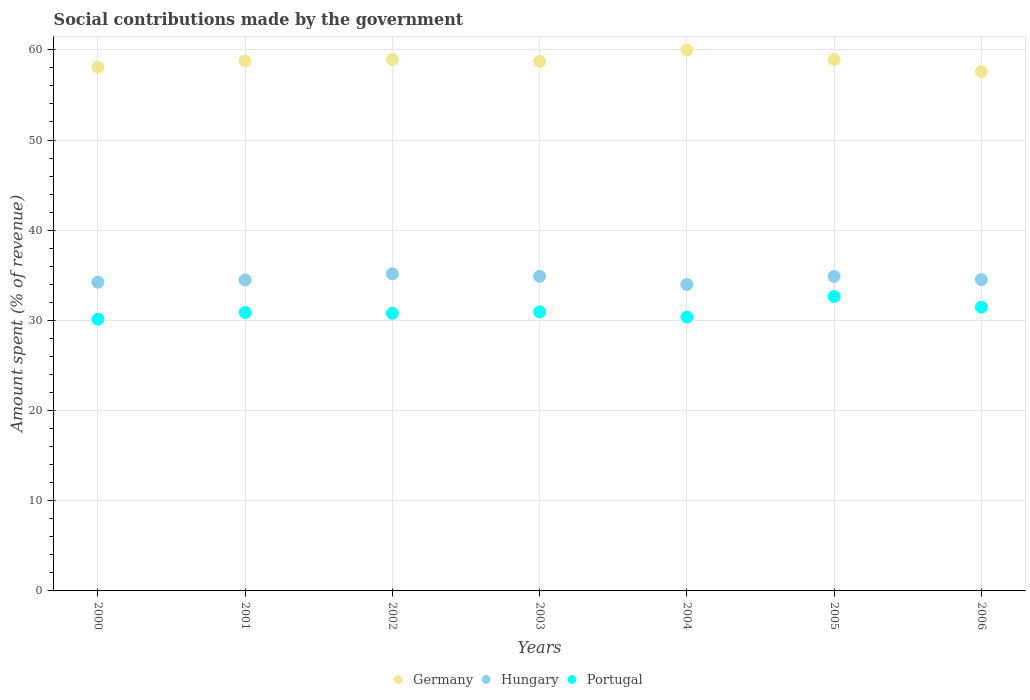What is the amount spent (in %) on social contributions in Portugal in 2006?
Your answer should be compact. 31.47. Across all years, what is the maximum amount spent (in %) on social contributions in Portugal?
Offer a terse response. 32.65. Across all years, what is the minimum amount spent (in %) on social contributions in Germany?
Offer a terse response. 57.59. In which year was the amount spent (in %) on social contributions in Portugal maximum?
Give a very brief answer. 2005. What is the total amount spent (in %) on social contributions in Portugal in the graph?
Provide a succinct answer. 217.23. What is the difference between the amount spent (in %) on social contributions in Hungary in 2005 and that in 2006?
Keep it short and to the point. 0.36. What is the difference between the amount spent (in %) on social contributions in Germany in 2003 and the amount spent (in %) on social contributions in Portugal in 2005?
Offer a very short reply. 26.08. What is the average amount spent (in %) on social contributions in Hungary per year?
Offer a very short reply. 34.59. In the year 2002, what is the difference between the amount spent (in %) on social contributions in Portugal and amount spent (in %) on social contributions in Hungary?
Offer a terse response. -4.37. In how many years, is the amount spent (in %) on social contributions in Germany greater than 14 %?
Your answer should be very brief. 7. What is the ratio of the amount spent (in %) on social contributions in Germany in 2001 to that in 2004?
Ensure brevity in your answer.  0.98. Is the amount spent (in %) on social contributions in Portugal in 2002 less than that in 2003?
Ensure brevity in your answer.  Yes. What is the difference between the highest and the second highest amount spent (in %) on social contributions in Portugal?
Give a very brief answer. 1.18. What is the difference between the highest and the lowest amount spent (in %) on social contributions in Portugal?
Ensure brevity in your answer.  2.52. In how many years, is the amount spent (in %) on social contributions in Portugal greater than the average amount spent (in %) on social contributions in Portugal taken over all years?
Provide a succinct answer. 2. Is the sum of the amount spent (in %) on social contributions in Hungary in 2001 and 2002 greater than the maximum amount spent (in %) on social contributions in Portugal across all years?
Your answer should be very brief. Yes. Is the amount spent (in %) on social contributions in Hungary strictly less than the amount spent (in %) on social contributions in Portugal over the years?
Make the answer very short. No. How many dotlines are there?
Make the answer very short. 3. How many years are there in the graph?
Your answer should be compact. 7. What is the difference between two consecutive major ticks on the Y-axis?
Your response must be concise. 10. Does the graph contain any zero values?
Offer a terse response. No. How many legend labels are there?
Give a very brief answer. 3. What is the title of the graph?
Offer a very short reply. Social contributions made by the government. Does "Pacific island small states" appear as one of the legend labels in the graph?
Your answer should be very brief. No. What is the label or title of the Y-axis?
Offer a very short reply. Amount spent (% of revenue). What is the Amount spent (% of revenue) of Germany in 2000?
Offer a terse response. 58.08. What is the Amount spent (% of revenue) in Hungary in 2000?
Your response must be concise. 34.24. What is the Amount spent (% of revenue) in Portugal in 2000?
Give a very brief answer. 30.13. What is the Amount spent (% of revenue) in Germany in 2001?
Provide a succinct answer. 58.78. What is the Amount spent (% of revenue) of Hungary in 2001?
Your answer should be very brief. 34.49. What is the Amount spent (% of revenue) in Portugal in 2001?
Give a very brief answer. 30.88. What is the Amount spent (% of revenue) of Germany in 2002?
Provide a succinct answer. 58.93. What is the Amount spent (% of revenue) in Hungary in 2002?
Offer a very short reply. 35.16. What is the Amount spent (% of revenue) of Portugal in 2002?
Your answer should be very brief. 30.79. What is the Amount spent (% of revenue) in Germany in 2003?
Make the answer very short. 58.73. What is the Amount spent (% of revenue) of Hungary in 2003?
Your answer should be compact. 34.89. What is the Amount spent (% of revenue) in Portugal in 2003?
Ensure brevity in your answer.  30.94. What is the Amount spent (% of revenue) in Germany in 2004?
Provide a short and direct response. 59.98. What is the Amount spent (% of revenue) in Hungary in 2004?
Your answer should be very brief. 33.98. What is the Amount spent (% of revenue) in Portugal in 2004?
Give a very brief answer. 30.37. What is the Amount spent (% of revenue) of Germany in 2005?
Your answer should be compact. 58.93. What is the Amount spent (% of revenue) of Hungary in 2005?
Give a very brief answer. 34.88. What is the Amount spent (% of revenue) in Portugal in 2005?
Offer a terse response. 32.65. What is the Amount spent (% of revenue) in Germany in 2006?
Offer a terse response. 57.59. What is the Amount spent (% of revenue) of Hungary in 2006?
Make the answer very short. 34.52. What is the Amount spent (% of revenue) in Portugal in 2006?
Offer a terse response. 31.47. Across all years, what is the maximum Amount spent (% of revenue) in Germany?
Keep it short and to the point. 59.98. Across all years, what is the maximum Amount spent (% of revenue) in Hungary?
Offer a very short reply. 35.16. Across all years, what is the maximum Amount spent (% of revenue) of Portugal?
Your answer should be compact. 32.65. Across all years, what is the minimum Amount spent (% of revenue) of Germany?
Make the answer very short. 57.59. Across all years, what is the minimum Amount spent (% of revenue) of Hungary?
Provide a short and direct response. 33.98. Across all years, what is the minimum Amount spent (% of revenue) of Portugal?
Offer a terse response. 30.13. What is the total Amount spent (% of revenue) in Germany in the graph?
Your response must be concise. 411.01. What is the total Amount spent (% of revenue) of Hungary in the graph?
Make the answer very short. 242.16. What is the total Amount spent (% of revenue) in Portugal in the graph?
Give a very brief answer. 217.23. What is the difference between the Amount spent (% of revenue) in Germany in 2000 and that in 2001?
Your answer should be compact. -0.71. What is the difference between the Amount spent (% of revenue) in Hungary in 2000 and that in 2001?
Offer a terse response. -0.24. What is the difference between the Amount spent (% of revenue) in Portugal in 2000 and that in 2001?
Make the answer very short. -0.75. What is the difference between the Amount spent (% of revenue) of Germany in 2000 and that in 2002?
Offer a very short reply. -0.85. What is the difference between the Amount spent (% of revenue) in Hungary in 2000 and that in 2002?
Your answer should be very brief. -0.92. What is the difference between the Amount spent (% of revenue) in Portugal in 2000 and that in 2002?
Your response must be concise. -0.66. What is the difference between the Amount spent (% of revenue) in Germany in 2000 and that in 2003?
Provide a succinct answer. -0.65. What is the difference between the Amount spent (% of revenue) in Hungary in 2000 and that in 2003?
Offer a terse response. -0.64. What is the difference between the Amount spent (% of revenue) of Portugal in 2000 and that in 2003?
Ensure brevity in your answer.  -0.81. What is the difference between the Amount spent (% of revenue) in Germany in 2000 and that in 2004?
Provide a succinct answer. -1.9. What is the difference between the Amount spent (% of revenue) in Hungary in 2000 and that in 2004?
Your response must be concise. 0.26. What is the difference between the Amount spent (% of revenue) of Portugal in 2000 and that in 2004?
Keep it short and to the point. -0.24. What is the difference between the Amount spent (% of revenue) in Germany in 2000 and that in 2005?
Provide a succinct answer. -0.85. What is the difference between the Amount spent (% of revenue) of Hungary in 2000 and that in 2005?
Your response must be concise. -0.64. What is the difference between the Amount spent (% of revenue) in Portugal in 2000 and that in 2005?
Ensure brevity in your answer.  -2.52. What is the difference between the Amount spent (% of revenue) of Germany in 2000 and that in 2006?
Give a very brief answer. 0.48. What is the difference between the Amount spent (% of revenue) of Hungary in 2000 and that in 2006?
Your answer should be compact. -0.28. What is the difference between the Amount spent (% of revenue) in Portugal in 2000 and that in 2006?
Provide a succinct answer. -1.34. What is the difference between the Amount spent (% of revenue) of Germany in 2001 and that in 2002?
Your answer should be compact. -0.14. What is the difference between the Amount spent (% of revenue) in Hungary in 2001 and that in 2002?
Give a very brief answer. -0.67. What is the difference between the Amount spent (% of revenue) in Portugal in 2001 and that in 2002?
Provide a succinct answer. 0.09. What is the difference between the Amount spent (% of revenue) of Germany in 2001 and that in 2003?
Keep it short and to the point. 0.06. What is the difference between the Amount spent (% of revenue) in Hungary in 2001 and that in 2003?
Keep it short and to the point. -0.4. What is the difference between the Amount spent (% of revenue) in Portugal in 2001 and that in 2003?
Make the answer very short. -0.06. What is the difference between the Amount spent (% of revenue) in Germany in 2001 and that in 2004?
Your answer should be compact. -1.2. What is the difference between the Amount spent (% of revenue) of Hungary in 2001 and that in 2004?
Give a very brief answer. 0.51. What is the difference between the Amount spent (% of revenue) in Portugal in 2001 and that in 2004?
Make the answer very short. 0.51. What is the difference between the Amount spent (% of revenue) of Germany in 2001 and that in 2005?
Make the answer very short. -0.15. What is the difference between the Amount spent (% of revenue) of Hungary in 2001 and that in 2005?
Your answer should be compact. -0.4. What is the difference between the Amount spent (% of revenue) of Portugal in 2001 and that in 2005?
Make the answer very short. -1.77. What is the difference between the Amount spent (% of revenue) of Germany in 2001 and that in 2006?
Offer a very short reply. 1.19. What is the difference between the Amount spent (% of revenue) of Hungary in 2001 and that in 2006?
Your response must be concise. -0.04. What is the difference between the Amount spent (% of revenue) of Portugal in 2001 and that in 2006?
Make the answer very short. -0.59. What is the difference between the Amount spent (% of revenue) in Germany in 2002 and that in 2003?
Your answer should be very brief. 0.2. What is the difference between the Amount spent (% of revenue) in Hungary in 2002 and that in 2003?
Make the answer very short. 0.27. What is the difference between the Amount spent (% of revenue) of Portugal in 2002 and that in 2003?
Your response must be concise. -0.16. What is the difference between the Amount spent (% of revenue) of Germany in 2002 and that in 2004?
Give a very brief answer. -1.05. What is the difference between the Amount spent (% of revenue) in Hungary in 2002 and that in 2004?
Make the answer very short. 1.18. What is the difference between the Amount spent (% of revenue) of Portugal in 2002 and that in 2004?
Your response must be concise. 0.42. What is the difference between the Amount spent (% of revenue) of Germany in 2002 and that in 2005?
Ensure brevity in your answer.  -0. What is the difference between the Amount spent (% of revenue) in Hungary in 2002 and that in 2005?
Provide a succinct answer. 0.27. What is the difference between the Amount spent (% of revenue) in Portugal in 2002 and that in 2005?
Your answer should be very brief. -1.86. What is the difference between the Amount spent (% of revenue) of Germany in 2002 and that in 2006?
Ensure brevity in your answer.  1.34. What is the difference between the Amount spent (% of revenue) in Hungary in 2002 and that in 2006?
Your answer should be compact. 0.63. What is the difference between the Amount spent (% of revenue) of Portugal in 2002 and that in 2006?
Provide a short and direct response. -0.68. What is the difference between the Amount spent (% of revenue) in Germany in 2003 and that in 2004?
Your response must be concise. -1.25. What is the difference between the Amount spent (% of revenue) in Hungary in 2003 and that in 2004?
Make the answer very short. 0.91. What is the difference between the Amount spent (% of revenue) of Portugal in 2003 and that in 2004?
Your response must be concise. 0.57. What is the difference between the Amount spent (% of revenue) of Germany in 2003 and that in 2005?
Keep it short and to the point. -0.2. What is the difference between the Amount spent (% of revenue) in Hungary in 2003 and that in 2005?
Offer a very short reply. 0. What is the difference between the Amount spent (% of revenue) of Portugal in 2003 and that in 2005?
Keep it short and to the point. -1.7. What is the difference between the Amount spent (% of revenue) in Germany in 2003 and that in 2006?
Give a very brief answer. 1.14. What is the difference between the Amount spent (% of revenue) in Hungary in 2003 and that in 2006?
Offer a terse response. 0.36. What is the difference between the Amount spent (% of revenue) of Portugal in 2003 and that in 2006?
Provide a succinct answer. -0.53. What is the difference between the Amount spent (% of revenue) of Germany in 2004 and that in 2005?
Provide a succinct answer. 1.05. What is the difference between the Amount spent (% of revenue) of Hungary in 2004 and that in 2005?
Your response must be concise. -0.9. What is the difference between the Amount spent (% of revenue) of Portugal in 2004 and that in 2005?
Your response must be concise. -2.28. What is the difference between the Amount spent (% of revenue) in Germany in 2004 and that in 2006?
Your answer should be compact. 2.39. What is the difference between the Amount spent (% of revenue) in Hungary in 2004 and that in 2006?
Your answer should be very brief. -0.54. What is the difference between the Amount spent (% of revenue) of Portugal in 2004 and that in 2006?
Your answer should be compact. -1.1. What is the difference between the Amount spent (% of revenue) in Germany in 2005 and that in 2006?
Keep it short and to the point. 1.34. What is the difference between the Amount spent (% of revenue) in Hungary in 2005 and that in 2006?
Keep it short and to the point. 0.36. What is the difference between the Amount spent (% of revenue) in Portugal in 2005 and that in 2006?
Your answer should be very brief. 1.18. What is the difference between the Amount spent (% of revenue) of Germany in 2000 and the Amount spent (% of revenue) of Hungary in 2001?
Give a very brief answer. 23.59. What is the difference between the Amount spent (% of revenue) of Germany in 2000 and the Amount spent (% of revenue) of Portugal in 2001?
Make the answer very short. 27.2. What is the difference between the Amount spent (% of revenue) in Hungary in 2000 and the Amount spent (% of revenue) in Portugal in 2001?
Keep it short and to the point. 3.36. What is the difference between the Amount spent (% of revenue) of Germany in 2000 and the Amount spent (% of revenue) of Hungary in 2002?
Make the answer very short. 22.92. What is the difference between the Amount spent (% of revenue) of Germany in 2000 and the Amount spent (% of revenue) of Portugal in 2002?
Keep it short and to the point. 27.29. What is the difference between the Amount spent (% of revenue) in Hungary in 2000 and the Amount spent (% of revenue) in Portugal in 2002?
Give a very brief answer. 3.45. What is the difference between the Amount spent (% of revenue) in Germany in 2000 and the Amount spent (% of revenue) in Hungary in 2003?
Offer a very short reply. 23.19. What is the difference between the Amount spent (% of revenue) of Germany in 2000 and the Amount spent (% of revenue) of Portugal in 2003?
Your response must be concise. 27.13. What is the difference between the Amount spent (% of revenue) of Hungary in 2000 and the Amount spent (% of revenue) of Portugal in 2003?
Offer a very short reply. 3.3. What is the difference between the Amount spent (% of revenue) of Germany in 2000 and the Amount spent (% of revenue) of Hungary in 2004?
Offer a terse response. 24.09. What is the difference between the Amount spent (% of revenue) of Germany in 2000 and the Amount spent (% of revenue) of Portugal in 2004?
Offer a terse response. 27.7. What is the difference between the Amount spent (% of revenue) in Hungary in 2000 and the Amount spent (% of revenue) in Portugal in 2004?
Provide a succinct answer. 3.87. What is the difference between the Amount spent (% of revenue) in Germany in 2000 and the Amount spent (% of revenue) in Hungary in 2005?
Provide a short and direct response. 23.19. What is the difference between the Amount spent (% of revenue) of Germany in 2000 and the Amount spent (% of revenue) of Portugal in 2005?
Ensure brevity in your answer.  25.43. What is the difference between the Amount spent (% of revenue) of Hungary in 2000 and the Amount spent (% of revenue) of Portugal in 2005?
Your answer should be very brief. 1.59. What is the difference between the Amount spent (% of revenue) of Germany in 2000 and the Amount spent (% of revenue) of Hungary in 2006?
Keep it short and to the point. 23.55. What is the difference between the Amount spent (% of revenue) of Germany in 2000 and the Amount spent (% of revenue) of Portugal in 2006?
Ensure brevity in your answer.  26.61. What is the difference between the Amount spent (% of revenue) in Hungary in 2000 and the Amount spent (% of revenue) in Portugal in 2006?
Offer a very short reply. 2.77. What is the difference between the Amount spent (% of revenue) of Germany in 2001 and the Amount spent (% of revenue) of Hungary in 2002?
Give a very brief answer. 23.63. What is the difference between the Amount spent (% of revenue) of Germany in 2001 and the Amount spent (% of revenue) of Portugal in 2002?
Your response must be concise. 28. What is the difference between the Amount spent (% of revenue) of Hungary in 2001 and the Amount spent (% of revenue) of Portugal in 2002?
Keep it short and to the point. 3.7. What is the difference between the Amount spent (% of revenue) in Germany in 2001 and the Amount spent (% of revenue) in Hungary in 2003?
Give a very brief answer. 23.9. What is the difference between the Amount spent (% of revenue) of Germany in 2001 and the Amount spent (% of revenue) of Portugal in 2003?
Ensure brevity in your answer.  27.84. What is the difference between the Amount spent (% of revenue) in Hungary in 2001 and the Amount spent (% of revenue) in Portugal in 2003?
Ensure brevity in your answer.  3.54. What is the difference between the Amount spent (% of revenue) of Germany in 2001 and the Amount spent (% of revenue) of Hungary in 2004?
Offer a very short reply. 24.8. What is the difference between the Amount spent (% of revenue) of Germany in 2001 and the Amount spent (% of revenue) of Portugal in 2004?
Provide a short and direct response. 28.41. What is the difference between the Amount spent (% of revenue) of Hungary in 2001 and the Amount spent (% of revenue) of Portugal in 2004?
Offer a terse response. 4.12. What is the difference between the Amount spent (% of revenue) in Germany in 2001 and the Amount spent (% of revenue) in Hungary in 2005?
Ensure brevity in your answer.  23.9. What is the difference between the Amount spent (% of revenue) of Germany in 2001 and the Amount spent (% of revenue) of Portugal in 2005?
Offer a terse response. 26.14. What is the difference between the Amount spent (% of revenue) in Hungary in 2001 and the Amount spent (% of revenue) in Portugal in 2005?
Your answer should be very brief. 1.84. What is the difference between the Amount spent (% of revenue) of Germany in 2001 and the Amount spent (% of revenue) of Hungary in 2006?
Keep it short and to the point. 24.26. What is the difference between the Amount spent (% of revenue) in Germany in 2001 and the Amount spent (% of revenue) in Portugal in 2006?
Offer a terse response. 27.31. What is the difference between the Amount spent (% of revenue) of Hungary in 2001 and the Amount spent (% of revenue) of Portugal in 2006?
Provide a succinct answer. 3.02. What is the difference between the Amount spent (% of revenue) of Germany in 2002 and the Amount spent (% of revenue) of Hungary in 2003?
Your answer should be very brief. 24.04. What is the difference between the Amount spent (% of revenue) of Germany in 2002 and the Amount spent (% of revenue) of Portugal in 2003?
Give a very brief answer. 27.98. What is the difference between the Amount spent (% of revenue) of Hungary in 2002 and the Amount spent (% of revenue) of Portugal in 2003?
Provide a short and direct response. 4.21. What is the difference between the Amount spent (% of revenue) of Germany in 2002 and the Amount spent (% of revenue) of Hungary in 2004?
Provide a succinct answer. 24.95. What is the difference between the Amount spent (% of revenue) in Germany in 2002 and the Amount spent (% of revenue) in Portugal in 2004?
Your answer should be very brief. 28.56. What is the difference between the Amount spent (% of revenue) of Hungary in 2002 and the Amount spent (% of revenue) of Portugal in 2004?
Make the answer very short. 4.79. What is the difference between the Amount spent (% of revenue) in Germany in 2002 and the Amount spent (% of revenue) in Hungary in 2005?
Your answer should be very brief. 24.05. What is the difference between the Amount spent (% of revenue) of Germany in 2002 and the Amount spent (% of revenue) of Portugal in 2005?
Give a very brief answer. 26.28. What is the difference between the Amount spent (% of revenue) in Hungary in 2002 and the Amount spent (% of revenue) in Portugal in 2005?
Offer a terse response. 2.51. What is the difference between the Amount spent (% of revenue) of Germany in 2002 and the Amount spent (% of revenue) of Hungary in 2006?
Give a very brief answer. 24.41. What is the difference between the Amount spent (% of revenue) of Germany in 2002 and the Amount spent (% of revenue) of Portugal in 2006?
Give a very brief answer. 27.46. What is the difference between the Amount spent (% of revenue) of Hungary in 2002 and the Amount spent (% of revenue) of Portugal in 2006?
Your answer should be very brief. 3.69. What is the difference between the Amount spent (% of revenue) of Germany in 2003 and the Amount spent (% of revenue) of Hungary in 2004?
Keep it short and to the point. 24.75. What is the difference between the Amount spent (% of revenue) of Germany in 2003 and the Amount spent (% of revenue) of Portugal in 2004?
Provide a succinct answer. 28.36. What is the difference between the Amount spent (% of revenue) in Hungary in 2003 and the Amount spent (% of revenue) in Portugal in 2004?
Your response must be concise. 4.51. What is the difference between the Amount spent (% of revenue) of Germany in 2003 and the Amount spent (% of revenue) of Hungary in 2005?
Provide a succinct answer. 23.84. What is the difference between the Amount spent (% of revenue) of Germany in 2003 and the Amount spent (% of revenue) of Portugal in 2005?
Offer a terse response. 26.08. What is the difference between the Amount spent (% of revenue) of Hungary in 2003 and the Amount spent (% of revenue) of Portugal in 2005?
Keep it short and to the point. 2.24. What is the difference between the Amount spent (% of revenue) in Germany in 2003 and the Amount spent (% of revenue) in Hungary in 2006?
Provide a short and direct response. 24.2. What is the difference between the Amount spent (% of revenue) of Germany in 2003 and the Amount spent (% of revenue) of Portugal in 2006?
Keep it short and to the point. 27.26. What is the difference between the Amount spent (% of revenue) in Hungary in 2003 and the Amount spent (% of revenue) in Portugal in 2006?
Offer a terse response. 3.42. What is the difference between the Amount spent (% of revenue) of Germany in 2004 and the Amount spent (% of revenue) of Hungary in 2005?
Make the answer very short. 25.1. What is the difference between the Amount spent (% of revenue) in Germany in 2004 and the Amount spent (% of revenue) in Portugal in 2005?
Your answer should be very brief. 27.33. What is the difference between the Amount spent (% of revenue) in Hungary in 2004 and the Amount spent (% of revenue) in Portugal in 2005?
Your response must be concise. 1.33. What is the difference between the Amount spent (% of revenue) of Germany in 2004 and the Amount spent (% of revenue) of Hungary in 2006?
Give a very brief answer. 25.46. What is the difference between the Amount spent (% of revenue) in Germany in 2004 and the Amount spent (% of revenue) in Portugal in 2006?
Your response must be concise. 28.51. What is the difference between the Amount spent (% of revenue) in Hungary in 2004 and the Amount spent (% of revenue) in Portugal in 2006?
Offer a terse response. 2.51. What is the difference between the Amount spent (% of revenue) of Germany in 2005 and the Amount spent (% of revenue) of Hungary in 2006?
Give a very brief answer. 24.41. What is the difference between the Amount spent (% of revenue) in Germany in 2005 and the Amount spent (% of revenue) in Portugal in 2006?
Keep it short and to the point. 27.46. What is the difference between the Amount spent (% of revenue) in Hungary in 2005 and the Amount spent (% of revenue) in Portugal in 2006?
Provide a succinct answer. 3.41. What is the average Amount spent (% of revenue) in Germany per year?
Offer a very short reply. 58.72. What is the average Amount spent (% of revenue) of Hungary per year?
Keep it short and to the point. 34.59. What is the average Amount spent (% of revenue) in Portugal per year?
Provide a short and direct response. 31.03. In the year 2000, what is the difference between the Amount spent (% of revenue) of Germany and Amount spent (% of revenue) of Hungary?
Keep it short and to the point. 23.83. In the year 2000, what is the difference between the Amount spent (% of revenue) in Germany and Amount spent (% of revenue) in Portugal?
Make the answer very short. 27.95. In the year 2000, what is the difference between the Amount spent (% of revenue) in Hungary and Amount spent (% of revenue) in Portugal?
Give a very brief answer. 4.11. In the year 2001, what is the difference between the Amount spent (% of revenue) of Germany and Amount spent (% of revenue) of Hungary?
Make the answer very short. 24.3. In the year 2001, what is the difference between the Amount spent (% of revenue) of Germany and Amount spent (% of revenue) of Portugal?
Provide a short and direct response. 27.9. In the year 2001, what is the difference between the Amount spent (% of revenue) of Hungary and Amount spent (% of revenue) of Portugal?
Your answer should be compact. 3.61. In the year 2002, what is the difference between the Amount spent (% of revenue) in Germany and Amount spent (% of revenue) in Hungary?
Keep it short and to the point. 23.77. In the year 2002, what is the difference between the Amount spent (% of revenue) of Germany and Amount spent (% of revenue) of Portugal?
Make the answer very short. 28.14. In the year 2002, what is the difference between the Amount spent (% of revenue) of Hungary and Amount spent (% of revenue) of Portugal?
Your response must be concise. 4.37. In the year 2003, what is the difference between the Amount spent (% of revenue) in Germany and Amount spent (% of revenue) in Hungary?
Your answer should be compact. 23.84. In the year 2003, what is the difference between the Amount spent (% of revenue) in Germany and Amount spent (% of revenue) in Portugal?
Provide a short and direct response. 27.78. In the year 2003, what is the difference between the Amount spent (% of revenue) in Hungary and Amount spent (% of revenue) in Portugal?
Offer a very short reply. 3.94. In the year 2004, what is the difference between the Amount spent (% of revenue) of Germany and Amount spent (% of revenue) of Hungary?
Give a very brief answer. 26. In the year 2004, what is the difference between the Amount spent (% of revenue) of Germany and Amount spent (% of revenue) of Portugal?
Ensure brevity in your answer.  29.61. In the year 2004, what is the difference between the Amount spent (% of revenue) in Hungary and Amount spent (% of revenue) in Portugal?
Keep it short and to the point. 3.61. In the year 2005, what is the difference between the Amount spent (% of revenue) in Germany and Amount spent (% of revenue) in Hungary?
Ensure brevity in your answer.  24.05. In the year 2005, what is the difference between the Amount spent (% of revenue) in Germany and Amount spent (% of revenue) in Portugal?
Make the answer very short. 26.28. In the year 2005, what is the difference between the Amount spent (% of revenue) of Hungary and Amount spent (% of revenue) of Portugal?
Your answer should be very brief. 2.23. In the year 2006, what is the difference between the Amount spent (% of revenue) in Germany and Amount spent (% of revenue) in Hungary?
Your answer should be very brief. 23.07. In the year 2006, what is the difference between the Amount spent (% of revenue) in Germany and Amount spent (% of revenue) in Portugal?
Your answer should be compact. 26.12. In the year 2006, what is the difference between the Amount spent (% of revenue) in Hungary and Amount spent (% of revenue) in Portugal?
Offer a terse response. 3.05. What is the ratio of the Amount spent (% of revenue) of Germany in 2000 to that in 2001?
Your response must be concise. 0.99. What is the ratio of the Amount spent (% of revenue) in Hungary in 2000 to that in 2001?
Offer a terse response. 0.99. What is the ratio of the Amount spent (% of revenue) of Portugal in 2000 to that in 2001?
Your answer should be very brief. 0.98. What is the ratio of the Amount spent (% of revenue) of Germany in 2000 to that in 2002?
Offer a terse response. 0.99. What is the ratio of the Amount spent (% of revenue) of Hungary in 2000 to that in 2002?
Your response must be concise. 0.97. What is the ratio of the Amount spent (% of revenue) in Portugal in 2000 to that in 2002?
Your response must be concise. 0.98. What is the ratio of the Amount spent (% of revenue) in Germany in 2000 to that in 2003?
Offer a terse response. 0.99. What is the ratio of the Amount spent (% of revenue) of Hungary in 2000 to that in 2003?
Provide a short and direct response. 0.98. What is the ratio of the Amount spent (% of revenue) in Portugal in 2000 to that in 2003?
Keep it short and to the point. 0.97. What is the ratio of the Amount spent (% of revenue) in Germany in 2000 to that in 2004?
Your answer should be very brief. 0.97. What is the ratio of the Amount spent (% of revenue) of Hungary in 2000 to that in 2004?
Provide a succinct answer. 1.01. What is the ratio of the Amount spent (% of revenue) in Germany in 2000 to that in 2005?
Keep it short and to the point. 0.99. What is the ratio of the Amount spent (% of revenue) of Hungary in 2000 to that in 2005?
Make the answer very short. 0.98. What is the ratio of the Amount spent (% of revenue) in Portugal in 2000 to that in 2005?
Your answer should be very brief. 0.92. What is the ratio of the Amount spent (% of revenue) in Germany in 2000 to that in 2006?
Provide a short and direct response. 1.01. What is the ratio of the Amount spent (% of revenue) in Hungary in 2000 to that in 2006?
Your answer should be very brief. 0.99. What is the ratio of the Amount spent (% of revenue) in Portugal in 2000 to that in 2006?
Provide a short and direct response. 0.96. What is the ratio of the Amount spent (% of revenue) in Hungary in 2001 to that in 2002?
Your answer should be very brief. 0.98. What is the ratio of the Amount spent (% of revenue) in Portugal in 2001 to that in 2002?
Keep it short and to the point. 1. What is the ratio of the Amount spent (% of revenue) in Germany in 2001 to that in 2003?
Offer a terse response. 1. What is the ratio of the Amount spent (% of revenue) in Hungary in 2001 to that in 2003?
Provide a short and direct response. 0.99. What is the ratio of the Amount spent (% of revenue) in Germany in 2001 to that in 2004?
Offer a very short reply. 0.98. What is the ratio of the Amount spent (% of revenue) of Hungary in 2001 to that in 2004?
Offer a very short reply. 1.01. What is the ratio of the Amount spent (% of revenue) of Portugal in 2001 to that in 2004?
Your answer should be compact. 1.02. What is the ratio of the Amount spent (% of revenue) of Germany in 2001 to that in 2005?
Your answer should be very brief. 1. What is the ratio of the Amount spent (% of revenue) in Portugal in 2001 to that in 2005?
Your answer should be very brief. 0.95. What is the ratio of the Amount spent (% of revenue) in Germany in 2001 to that in 2006?
Make the answer very short. 1.02. What is the ratio of the Amount spent (% of revenue) in Hungary in 2001 to that in 2006?
Offer a very short reply. 1. What is the ratio of the Amount spent (% of revenue) of Portugal in 2001 to that in 2006?
Offer a terse response. 0.98. What is the ratio of the Amount spent (% of revenue) of Germany in 2002 to that in 2003?
Offer a very short reply. 1. What is the ratio of the Amount spent (% of revenue) in Portugal in 2002 to that in 2003?
Your response must be concise. 0.99. What is the ratio of the Amount spent (% of revenue) in Germany in 2002 to that in 2004?
Keep it short and to the point. 0.98. What is the ratio of the Amount spent (% of revenue) in Hungary in 2002 to that in 2004?
Offer a terse response. 1.03. What is the ratio of the Amount spent (% of revenue) of Portugal in 2002 to that in 2004?
Offer a terse response. 1.01. What is the ratio of the Amount spent (% of revenue) of Germany in 2002 to that in 2005?
Keep it short and to the point. 1. What is the ratio of the Amount spent (% of revenue) in Hungary in 2002 to that in 2005?
Your answer should be very brief. 1.01. What is the ratio of the Amount spent (% of revenue) of Portugal in 2002 to that in 2005?
Offer a very short reply. 0.94. What is the ratio of the Amount spent (% of revenue) of Germany in 2002 to that in 2006?
Give a very brief answer. 1.02. What is the ratio of the Amount spent (% of revenue) of Hungary in 2002 to that in 2006?
Offer a terse response. 1.02. What is the ratio of the Amount spent (% of revenue) of Portugal in 2002 to that in 2006?
Offer a terse response. 0.98. What is the ratio of the Amount spent (% of revenue) of Germany in 2003 to that in 2004?
Offer a terse response. 0.98. What is the ratio of the Amount spent (% of revenue) in Hungary in 2003 to that in 2004?
Offer a very short reply. 1.03. What is the ratio of the Amount spent (% of revenue) in Portugal in 2003 to that in 2004?
Provide a short and direct response. 1.02. What is the ratio of the Amount spent (% of revenue) of Hungary in 2003 to that in 2005?
Your answer should be compact. 1. What is the ratio of the Amount spent (% of revenue) in Portugal in 2003 to that in 2005?
Offer a terse response. 0.95. What is the ratio of the Amount spent (% of revenue) in Germany in 2003 to that in 2006?
Provide a short and direct response. 1.02. What is the ratio of the Amount spent (% of revenue) in Hungary in 2003 to that in 2006?
Your response must be concise. 1.01. What is the ratio of the Amount spent (% of revenue) in Portugal in 2003 to that in 2006?
Ensure brevity in your answer.  0.98. What is the ratio of the Amount spent (% of revenue) of Germany in 2004 to that in 2005?
Offer a very short reply. 1.02. What is the ratio of the Amount spent (% of revenue) of Hungary in 2004 to that in 2005?
Offer a terse response. 0.97. What is the ratio of the Amount spent (% of revenue) in Portugal in 2004 to that in 2005?
Give a very brief answer. 0.93. What is the ratio of the Amount spent (% of revenue) of Germany in 2004 to that in 2006?
Give a very brief answer. 1.04. What is the ratio of the Amount spent (% of revenue) of Hungary in 2004 to that in 2006?
Your answer should be very brief. 0.98. What is the ratio of the Amount spent (% of revenue) in Portugal in 2004 to that in 2006?
Provide a succinct answer. 0.97. What is the ratio of the Amount spent (% of revenue) in Germany in 2005 to that in 2006?
Your answer should be compact. 1.02. What is the ratio of the Amount spent (% of revenue) of Hungary in 2005 to that in 2006?
Keep it short and to the point. 1.01. What is the ratio of the Amount spent (% of revenue) in Portugal in 2005 to that in 2006?
Your answer should be compact. 1.04. What is the difference between the highest and the second highest Amount spent (% of revenue) of Germany?
Your response must be concise. 1.05. What is the difference between the highest and the second highest Amount spent (% of revenue) in Hungary?
Keep it short and to the point. 0.27. What is the difference between the highest and the second highest Amount spent (% of revenue) of Portugal?
Give a very brief answer. 1.18. What is the difference between the highest and the lowest Amount spent (% of revenue) of Germany?
Keep it short and to the point. 2.39. What is the difference between the highest and the lowest Amount spent (% of revenue) in Hungary?
Your answer should be very brief. 1.18. What is the difference between the highest and the lowest Amount spent (% of revenue) of Portugal?
Provide a short and direct response. 2.52. 